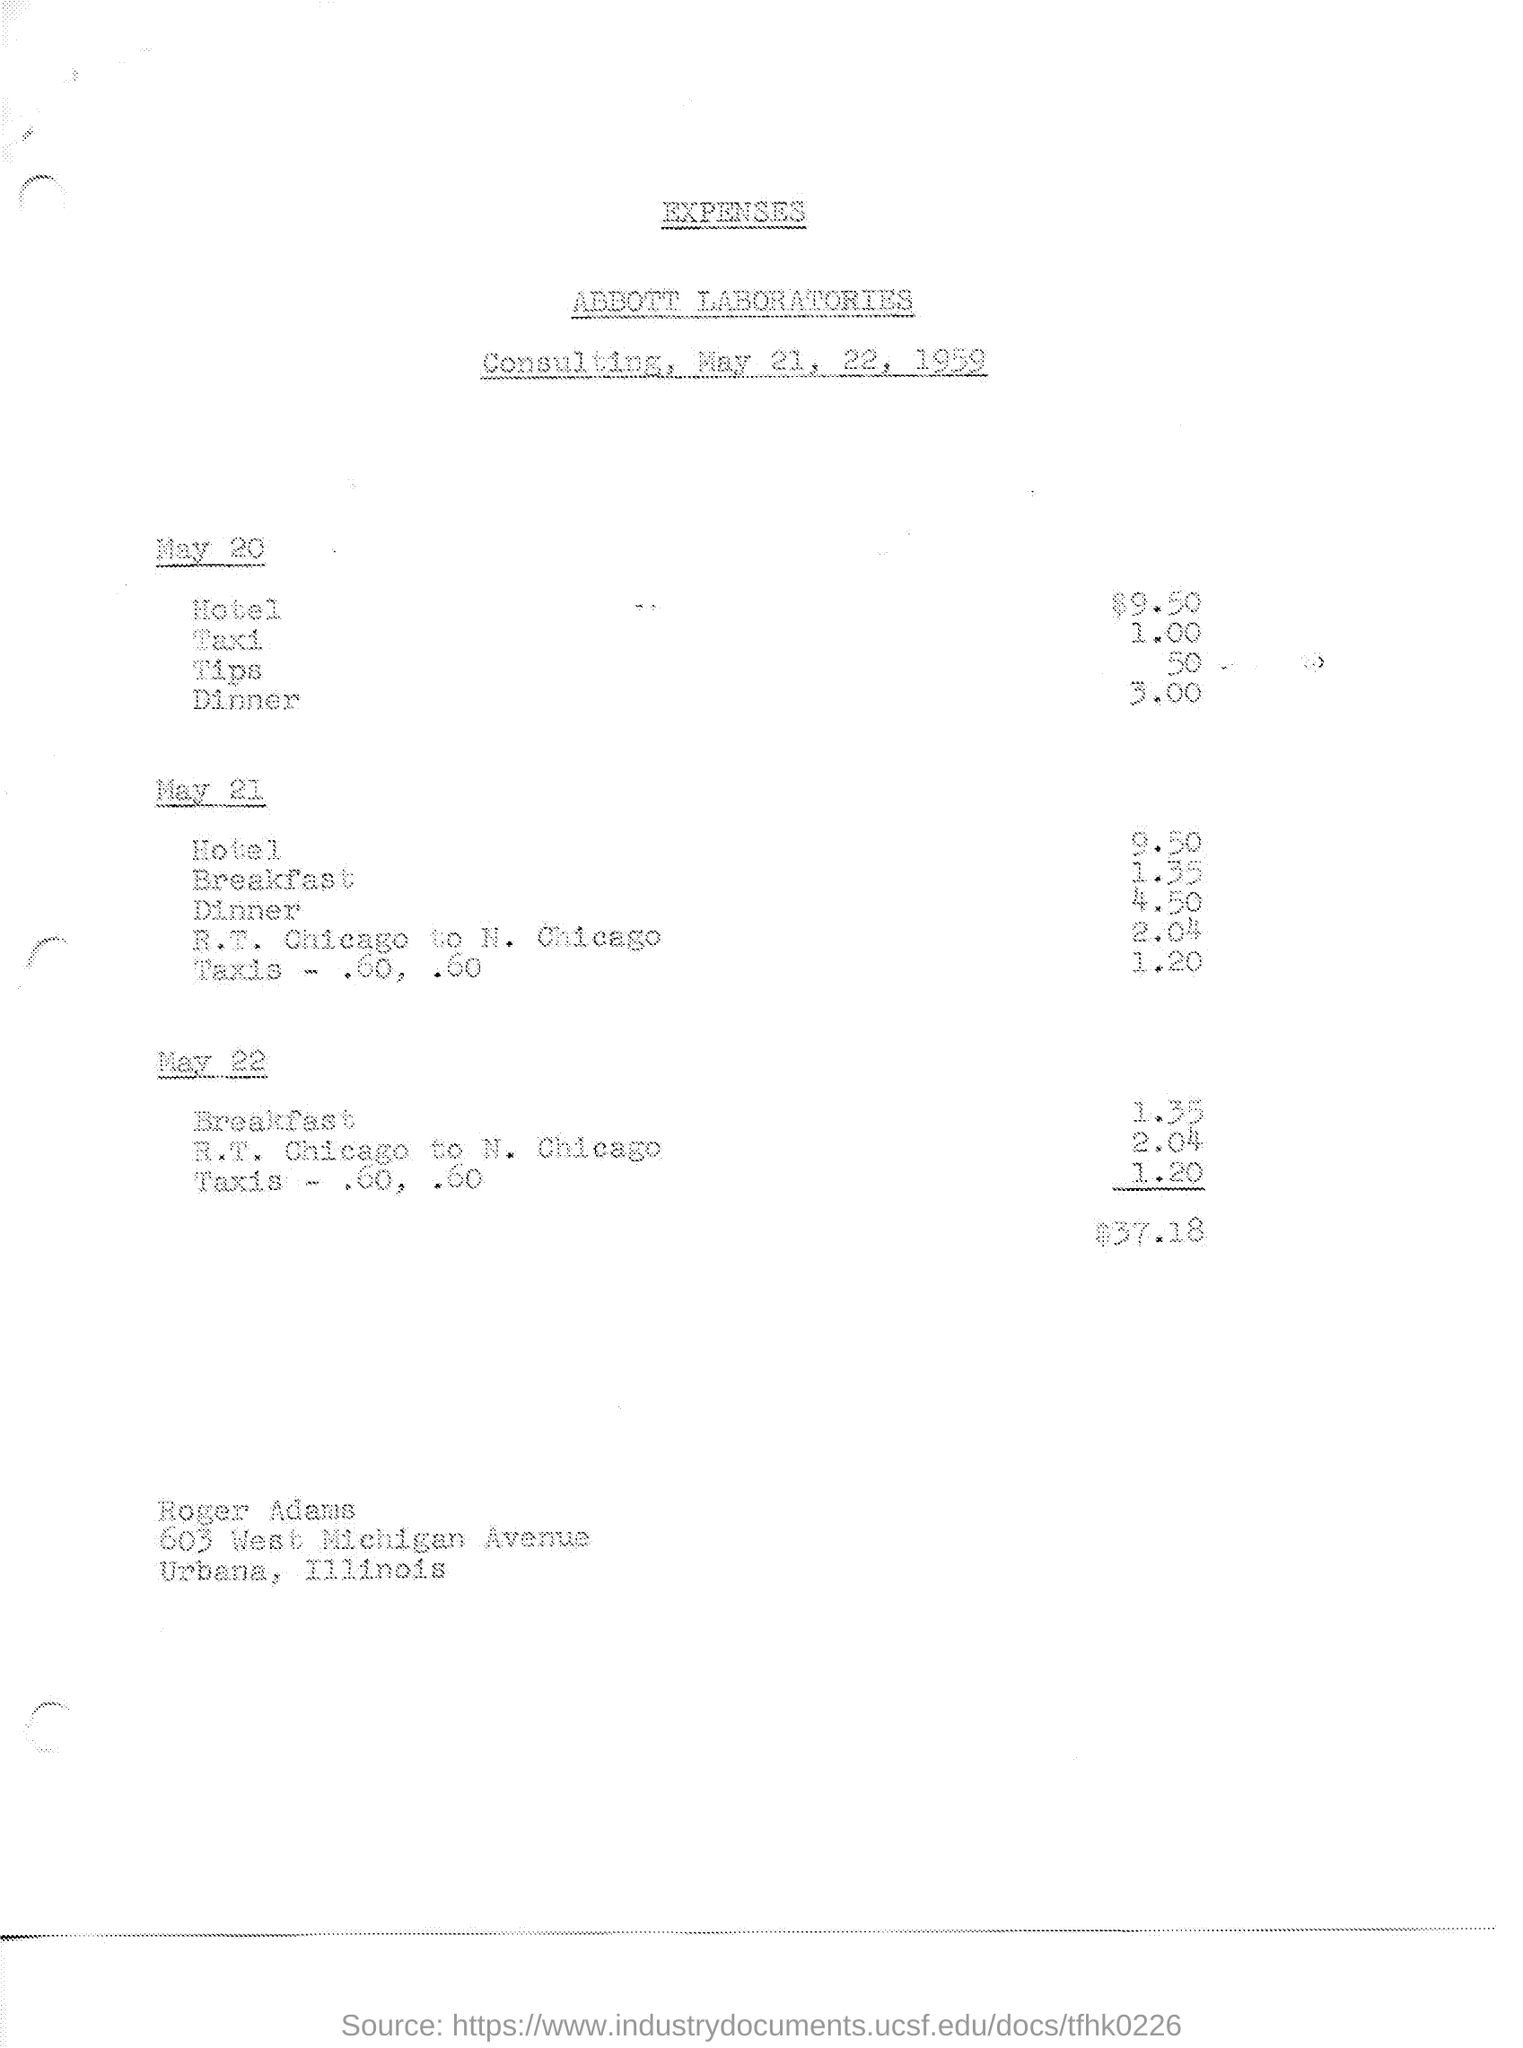What is the document title?
Your answer should be compact. Expenses. Which laboratory is mentioned?
Your answer should be very brief. ABBOTT LABORATORIES. When is the Consulting?
Your answer should be compact. May 21, 22, 1959. 